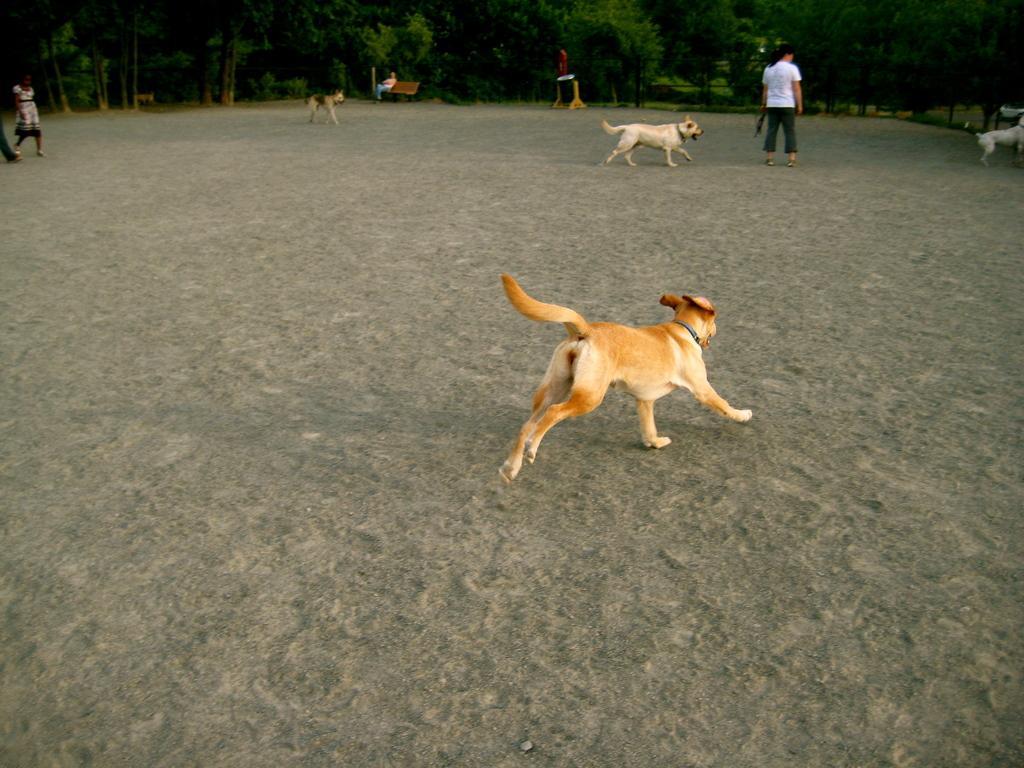Describe this image in one or two sentences. In the image we can see there are dogs running, this is a sand, object, bench and trees. There are people wearing clothes and there is a person sitting on the bench. 